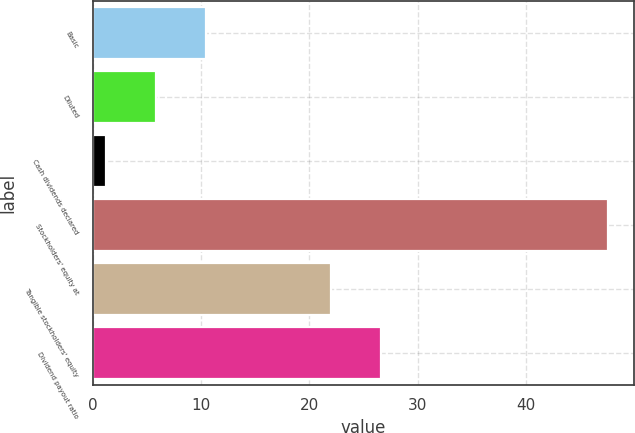Convert chart. <chart><loc_0><loc_0><loc_500><loc_500><bar_chart><fcel>Basic<fcel>Diluted<fcel>Cash dividends declared<fcel>Stockholders' equity at<fcel>Tangible stockholders' equity<fcel>Dividend payout ratio<nl><fcel>10.46<fcel>5.83<fcel>1.2<fcel>47.55<fcel>21.97<fcel>26.6<nl></chart> 